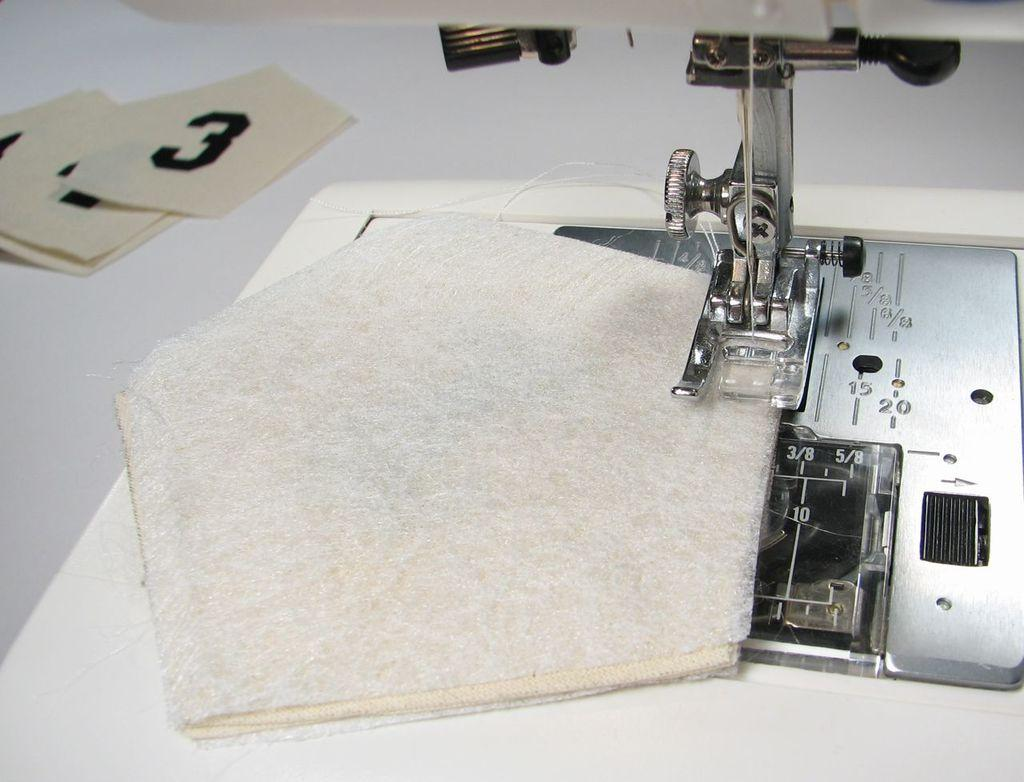What is the main object in the image? There is a cloth in the image. What is the cloth placed on? The cloth is on a stitching machine. What language is spoken by the cloth in the image? The cloth does not speak a language, as it is an inanimate object. 